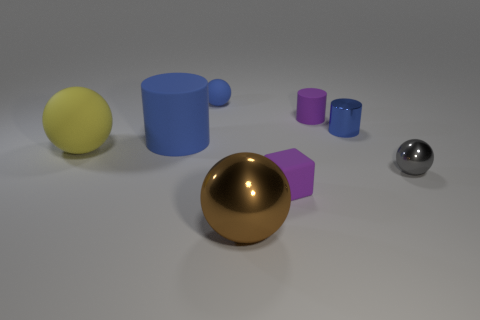Add 1 large brown spheres. How many objects exist? 9 Subtract all cylinders. How many objects are left? 5 Subtract 1 yellow spheres. How many objects are left? 7 Subtract all brown spheres. Subtract all blocks. How many objects are left? 6 Add 1 small blue rubber objects. How many small blue rubber objects are left? 2 Add 6 large red shiny cylinders. How many large red shiny cylinders exist? 6 